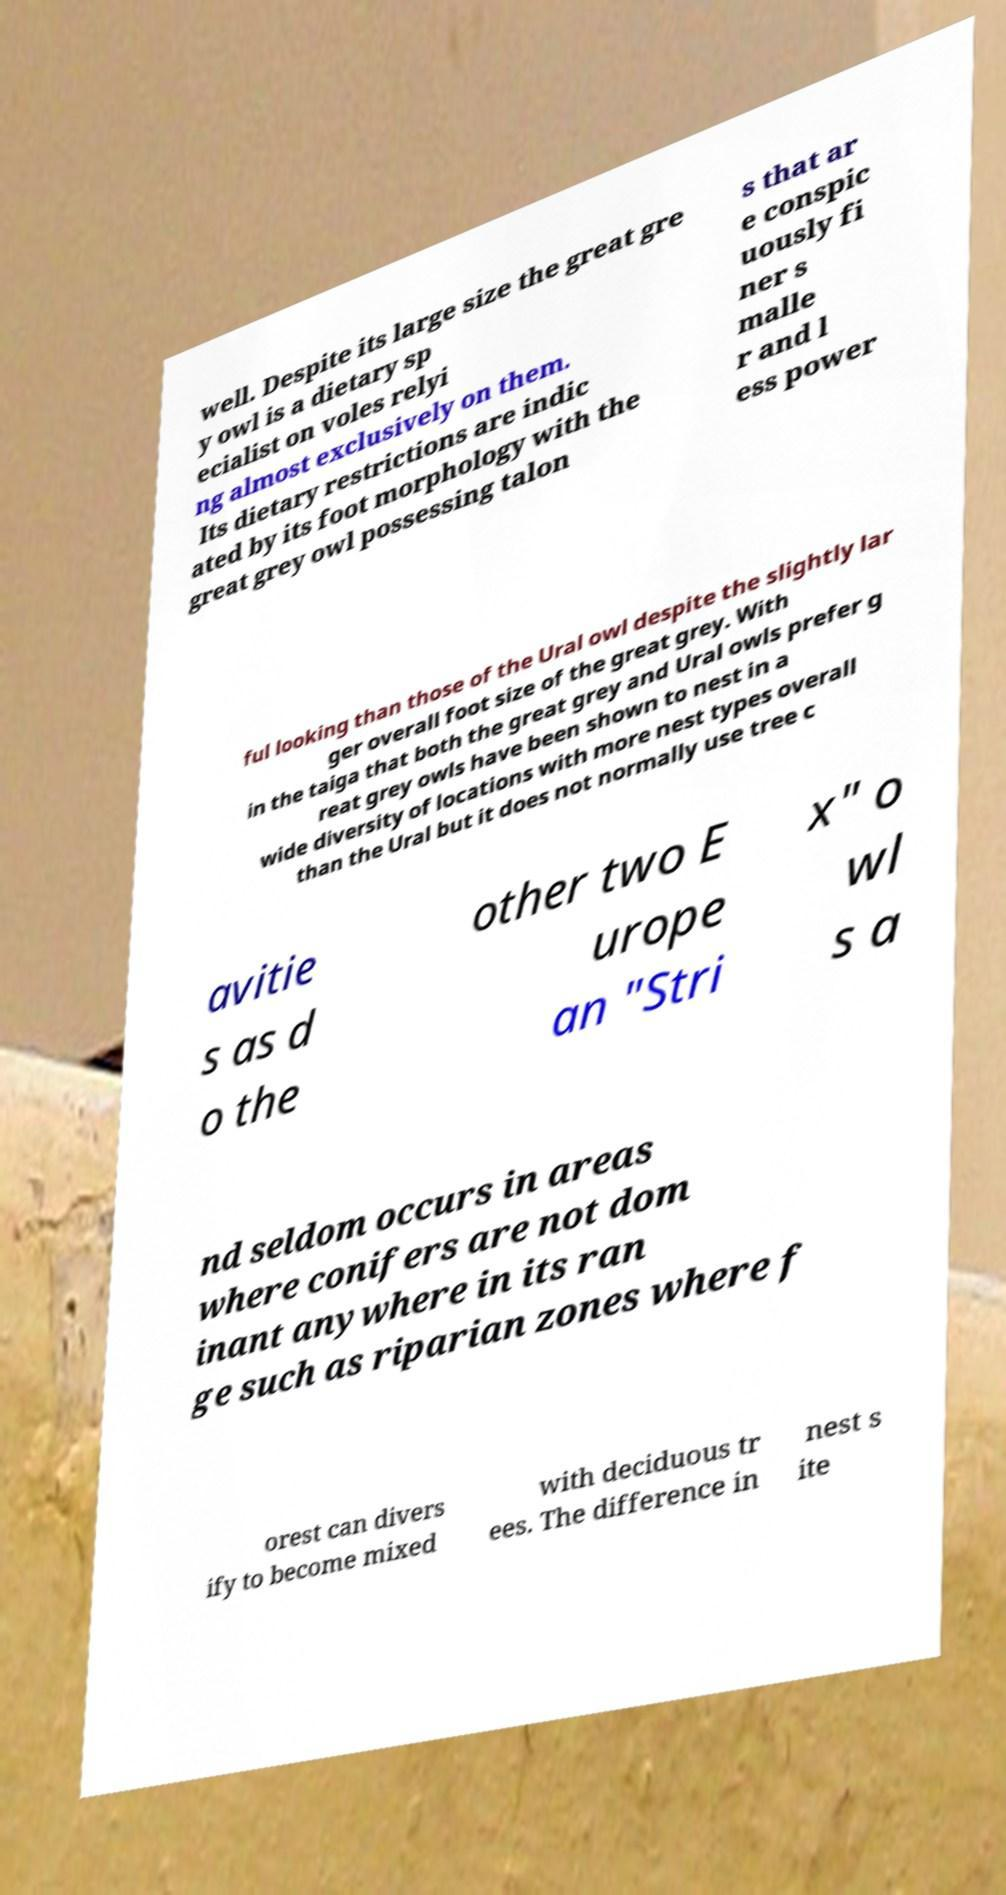Please identify and transcribe the text found in this image. well. Despite its large size the great gre y owl is a dietary sp ecialist on voles relyi ng almost exclusively on them. Its dietary restrictions are indic ated by its foot morphology with the great grey owl possessing talon s that ar e conspic uously fi ner s malle r and l ess power ful looking than those of the Ural owl despite the slightly lar ger overall foot size of the great grey. With in the taiga that both the great grey and Ural owls prefer g reat grey owls have been shown to nest in a wide diversity of locations with more nest types overall than the Ural but it does not normally use tree c avitie s as d o the other two E urope an "Stri x" o wl s a nd seldom occurs in areas where conifers are not dom inant anywhere in its ran ge such as riparian zones where f orest can divers ify to become mixed with deciduous tr ees. The difference in nest s ite 